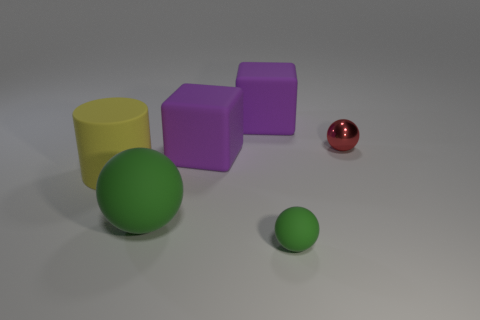Is there any other thing that has the same material as the red object?
Your answer should be compact. No. What material is the other sphere that is the same color as the big rubber ball?
Keep it short and to the point. Rubber. There is a sphere that is behind the big green thing; what size is it?
Your answer should be very brief. Small. What material is the cylinder?
Ensure brevity in your answer.  Rubber. How many things are either small objects behind the big green matte sphere or large purple objects that are in front of the tiny red shiny ball?
Your answer should be very brief. 2. How many other things are there of the same color as the big sphere?
Give a very brief answer. 1. There is a big green matte thing; is it the same shape as the purple thing that is in front of the tiny metal ball?
Offer a terse response. No. Is the number of small matte balls that are on the left side of the matte cylinder less than the number of large cylinders on the right side of the tiny red ball?
Your answer should be compact. No. There is a large green object that is the same shape as the red metal object; what is its material?
Your response must be concise. Rubber. Is the color of the cylinder the same as the large ball?
Provide a short and direct response. No. 